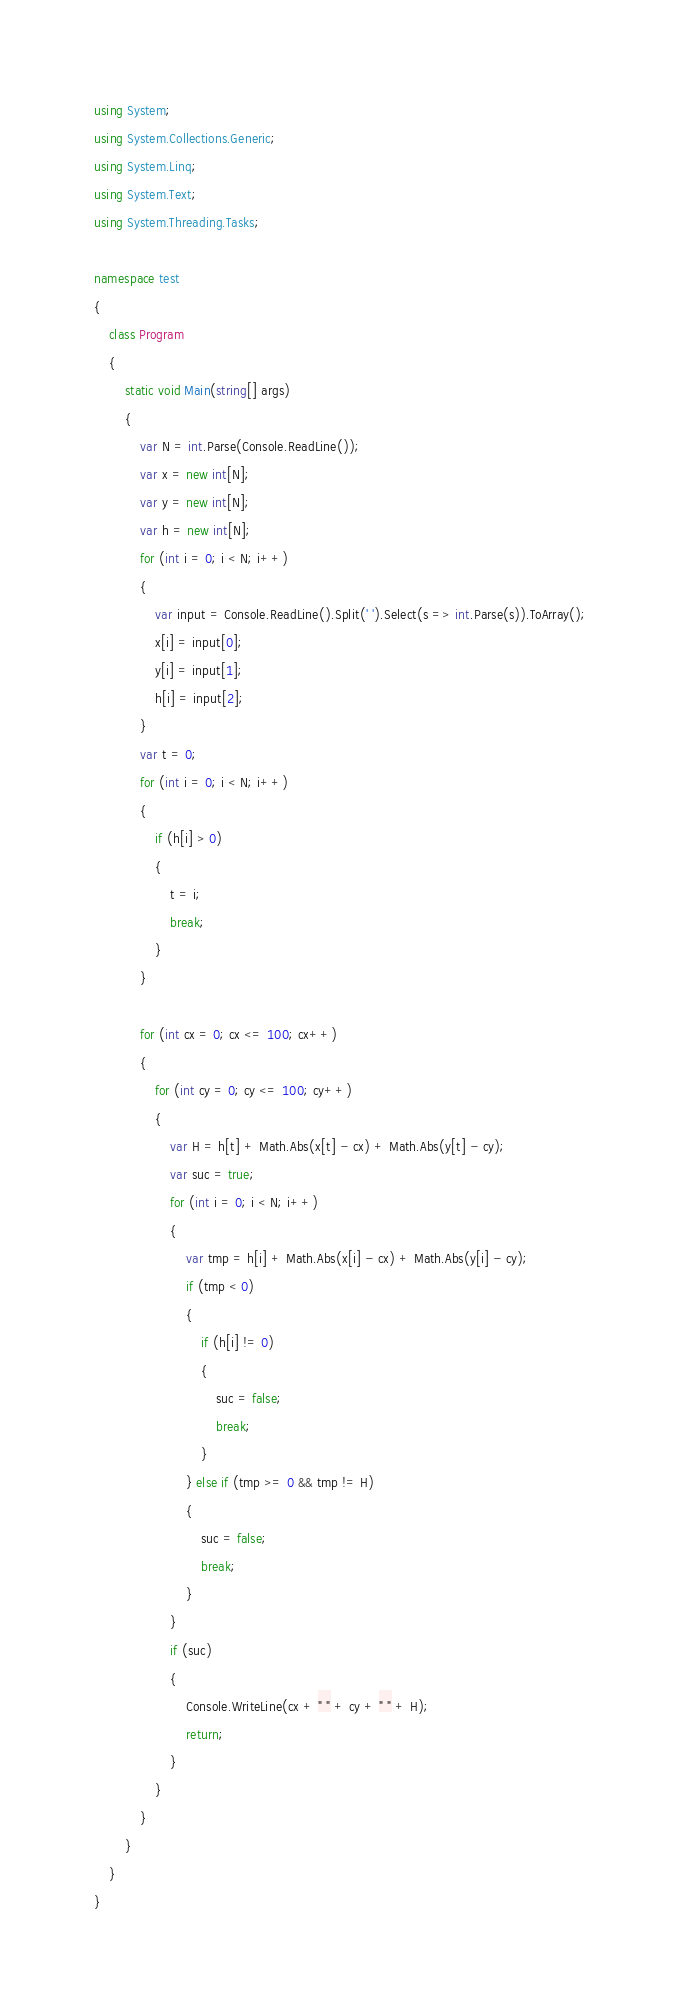Convert code to text. <code><loc_0><loc_0><loc_500><loc_500><_C#_>using System;
using System.Collections.Generic;
using System.Linq;
using System.Text;
using System.Threading.Tasks;

namespace test
{
    class Program
    {
        static void Main(string[] args)
        {
            var N = int.Parse(Console.ReadLine());
            var x = new int[N];
            var y = new int[N];
            var h = new int[N];
            for (int i = 0; i < N; i++)
            {
                var input = Console.ReadLine().Split(' ').Select(s => int.Parse(s)).ToArray();
                x[i] = input[0];
                y[i] = input[1];
                h[i] = input[2];
            }
            var t = 0;
            for (int i = 0; i < N; i++)
            {
                if (h[i] > 0)
                {
                    t = i;
                    break;
                }
            }

            for (int cx = 0; cx <= 100; cx++)
            {
                for (int cy = 0; cy <= 100; cy++)
                {
                    var H = h[t] + Math.Abs(x[t] - cx) + Math.Abs(y[t] - cy);
                    var suc = true;
                    for (int i = 0; i < N; i++)
                    {
                        var tmp = h[i] + Math.Abs(x[i] - cx) + Math.Abs(y[i] - cy);
                        if (tmp < 0)
                        {
                            if (h[i] != 0)
                            {
                                suc = false;
                                break;
                            }
                        } else if (tmp >= 0 && tmp != H)
                        {
                            suc = false;
                            break;
                        }
                    }
                    if (suc)
                    {
                        Console.WriteLine(cx + " " + cy + " " + H);
                        return;
                    }
                }
            }
        }
    }
}</code> 